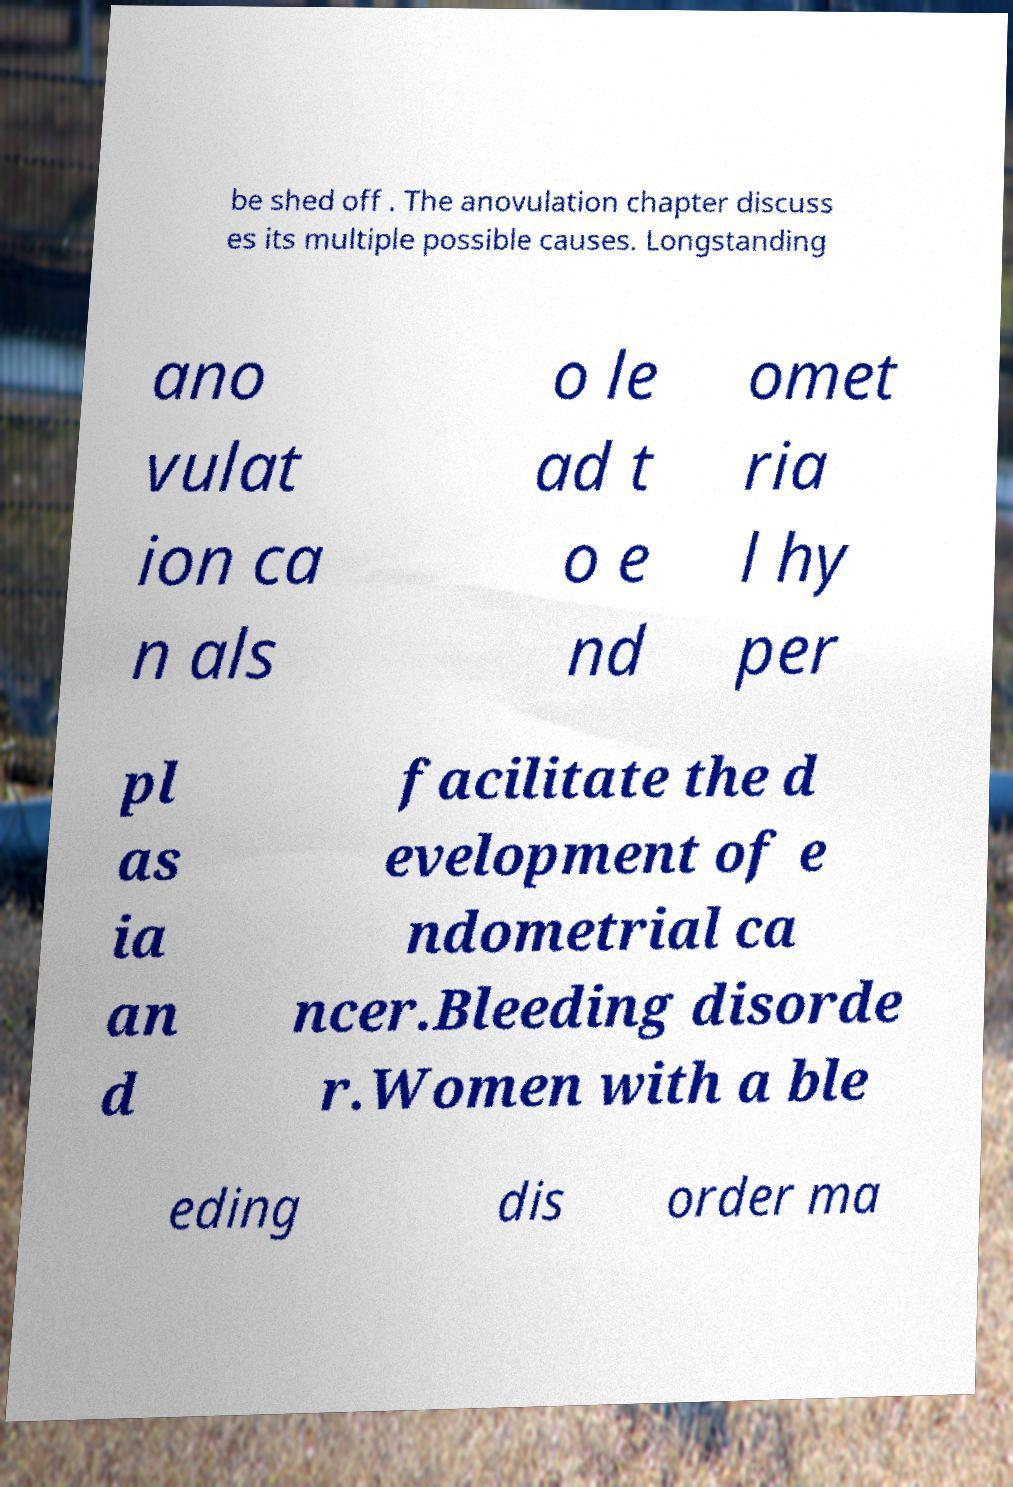Please identify and transcribe the text found in this image. be shed off . The anovulation chapter discuss es its multiple possible causes. Longstanding ano vulat ion ca n als o le ad t o e nd omet ria l hy per pl as ia an d facilitate the d evelopment of e ndometrial ca ncer.Bleeding disorde r.Women with a ble eding dis order ma 